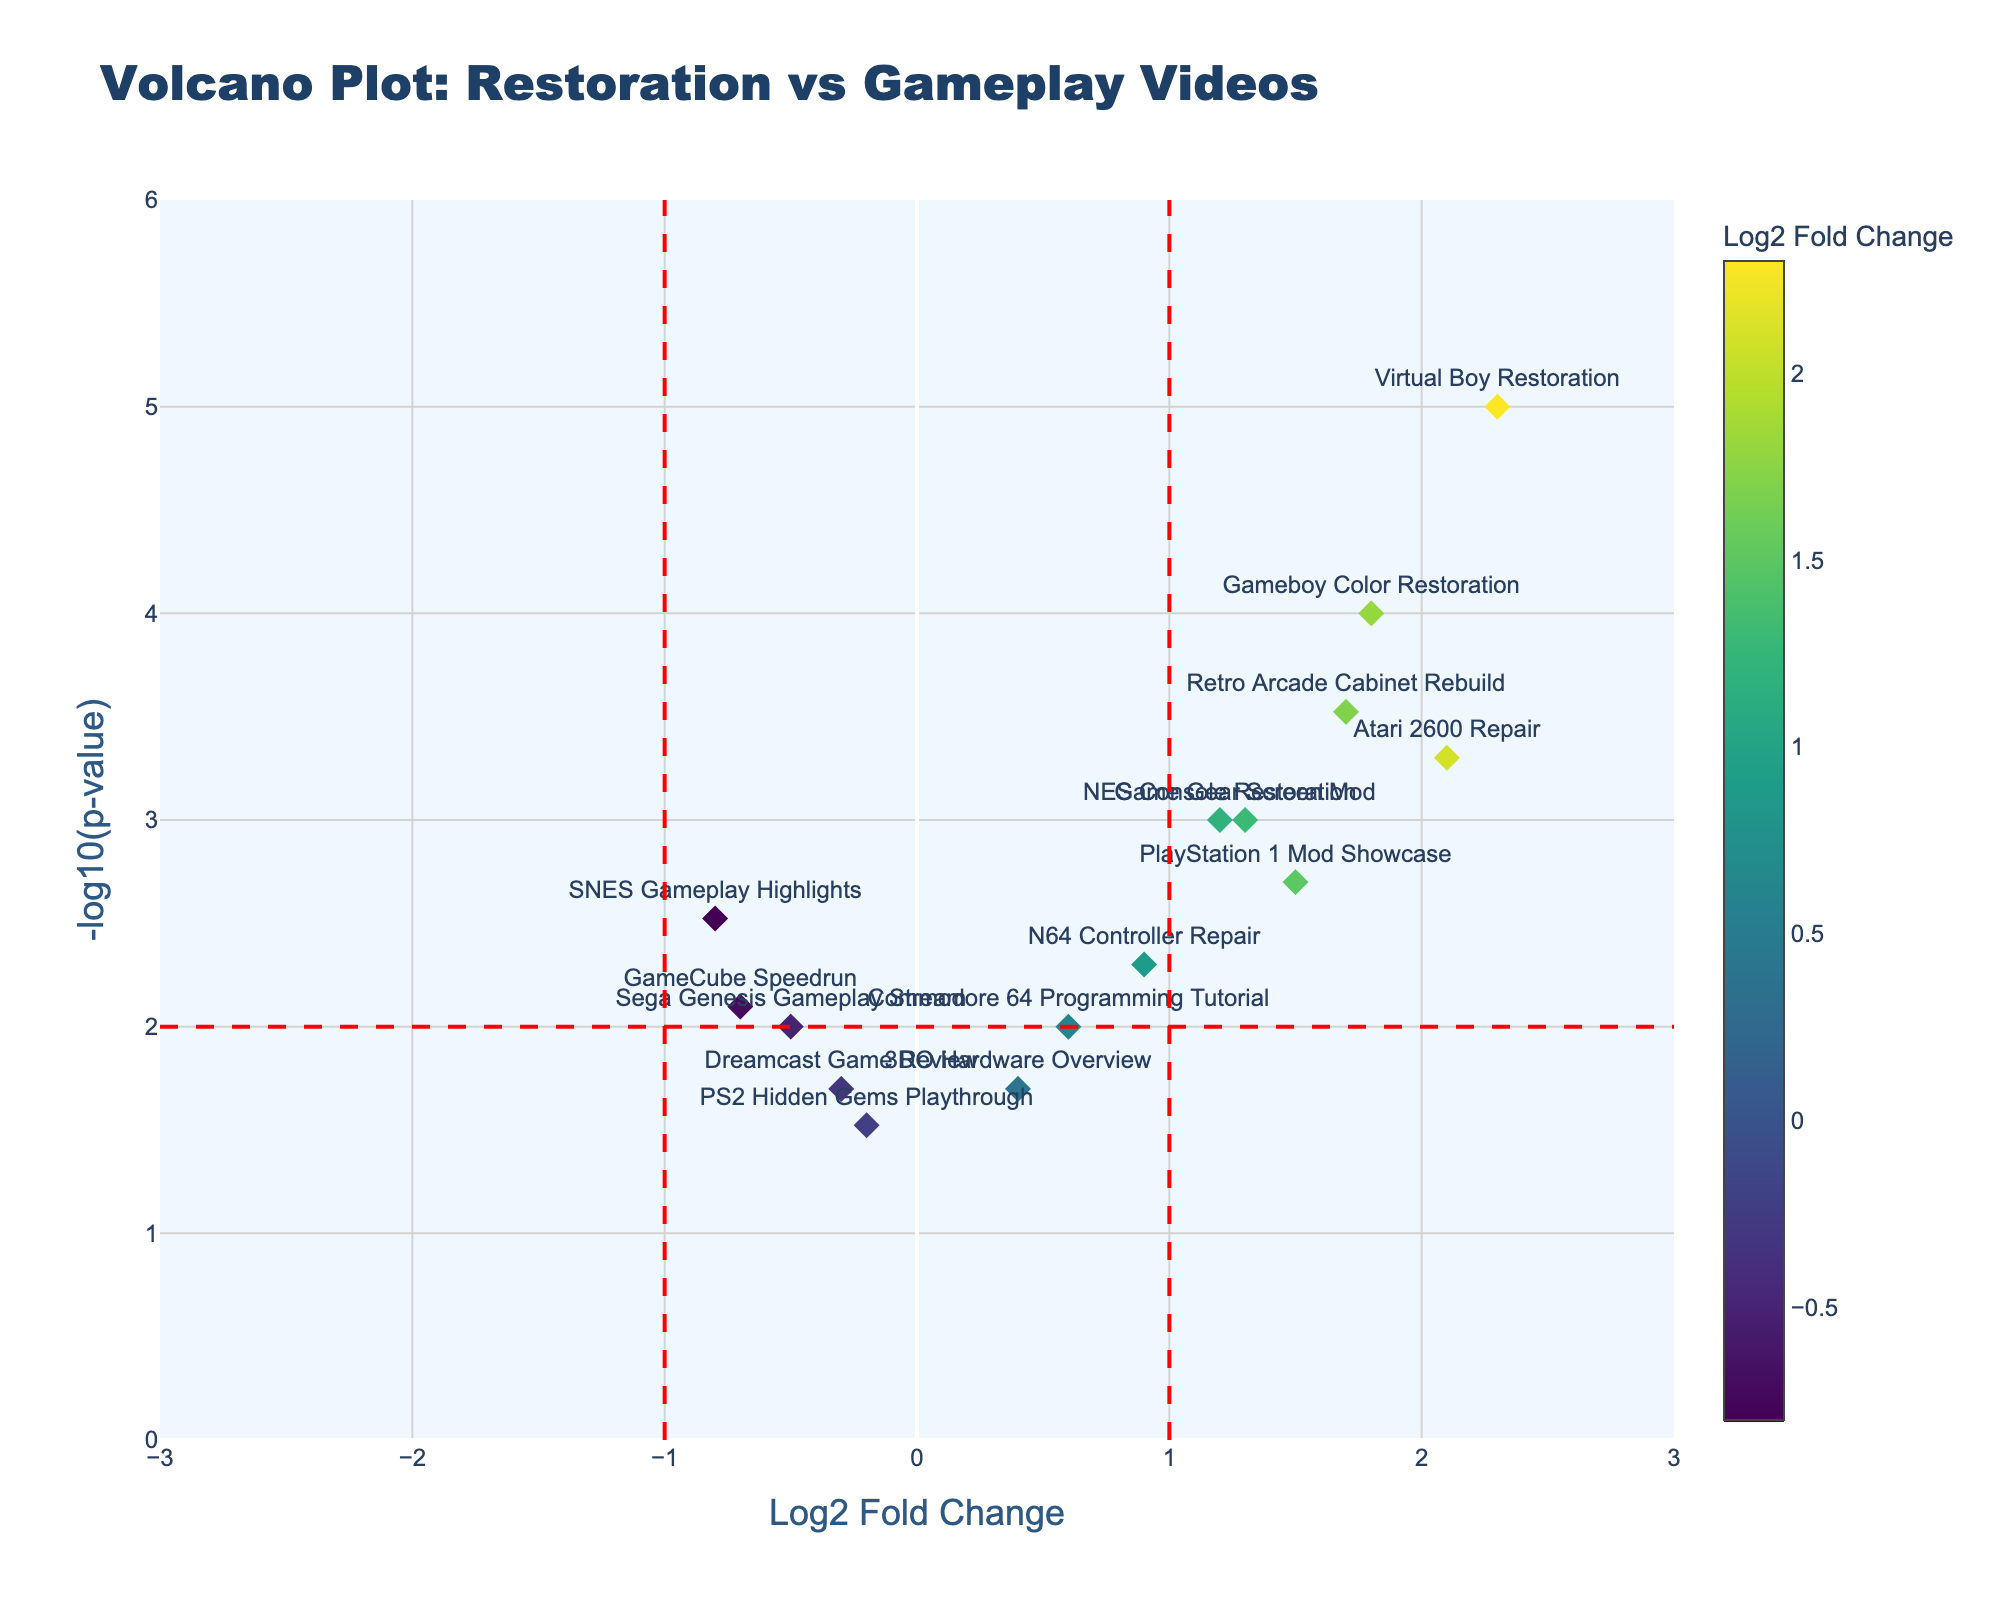Which video type has the highest log2 fold change? Look at the x-axis to find the highest value for log2 fold change and identify the corresponding video type.
Answer: Virtual Boy Restoration What is the title of the volcano plot? Examine the top of the plot for the title text.
Answer: Volcano Plot: Restoration vs Gameplay Videos How does the log2 fold change for NES Console Restoration compare with SNES Gameplay Highlights? Note that the NES Console Restoration has a log2 fold change of 1.2, while SNES Gameplay Highlights has -0.8; NES Console Restoration has a higher log2 fold change.
Answer: NES Console Restoration has a higher log2 fold change What is the p-value for the Virtual Boy Restoration video type? Using the hovertext or by identifying the point on the graph, find the p-value for Virtual Boy Restoration, which is noted with the smallest p-value spot.
Answer: 0.00001 Which video types fall outside the threshold lines for log2 fold change? Check the points that fall beyond the log2 fold change threshold lines at -1 and 1.
Answer: NES Console Restoration, Atari 2600 Repair, PlayStation 1 Mod Showcase, Gameboy Color Restoration, Virtual Boy Restoration, Retro Arcade Cabinet Rebuild, Game Gear Screen Mod What is the range of -log10(p-value) in this plot? Look at the y-axis to determine the extent of the -log10(p-value) values.
Answer: 0 to 6 Count the number of restoration video types with p-values less than 0.001. Identify all points below the p-value of 0.001 (with a -log10(p-value) higher than 3) and count them.
Answer: 5 What visual element represents the significance threshold for p-value? Identify the visual feature in the plot that signifies the p-value threshold, which is typically a horizontal line.
Answer: Horizontal red dashed line Which video type has the lowest -log10(p-value)? Find the point with the lowest value on the y-axis (-log10(p-value)) and identify its corresponding video type.
Answer: PS2 Hidden Gems Playthrough Compare and contrast the viewer engagement for GameCube Speedrun vs. Sega Genesis Gameplay Stream. Note the log2 fold change and -log10(p-value) for both: GameCube Speedrun is at a log2 fold change of -0.7 and p-value 0.008, whereas Sega Genesis Gameplay Stream has log2 fold change of -0.5 and p-value 0.01. Compare the visual and numerical differences.
Answer: GameCube Speedrun has lower viewer engagement based on log2 fold change and a slightly more significant p-value 